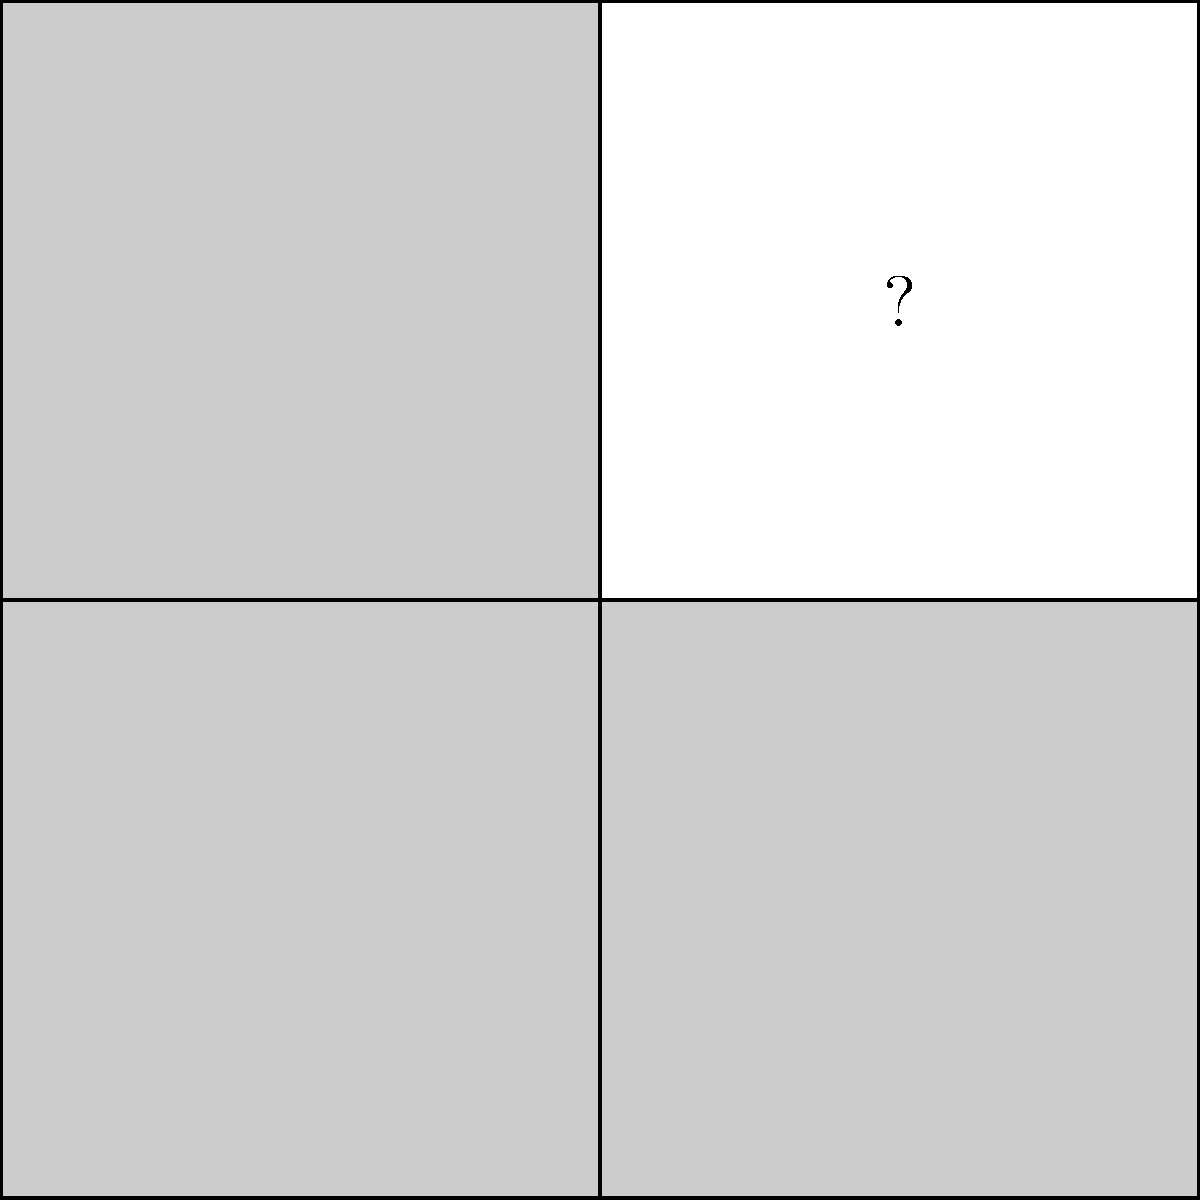In the geometric puzzle above, identify the shape and position of the missing piece that completes the square grid, ensuring a seamless conversion of the incomplete structure into a fully formed square. To identify the missing piece, let's follow these steps:

1. Observe the overall structure: The puzzle forms a 2x2 grid of squares.

2. Analyze the existing pieces:
   - There are three filled squares in the grid.
   - The filled squares occupy the top-left, top-right, and bottom-left positions.

3. Identify the missing area:
   - The bottom-right square is missing, indicated by the "?" symbol.

4. Determine the required shape:
   - To complete the 2x2 grid, we need a square piece.
   - The square should have the same dimensions as the existing pieces to maintain consistency.

5. Consider the position:
   - The missing piece should fit in the bottom-right corner of the grid.
   - It should connect seamlessly with the adjacent pieces on its left and top sides.

6. Visualize the solution:
   - A square piece in the bottom-right position would complete the puzzle, creating a perfect 2x2 grid without any gaps or overlaps.

Therefore, the missing piece should be a square that fits in the bottom-right corner of the grid, completing the 2x2 structure.
Answer: A square in the bottom-right position 